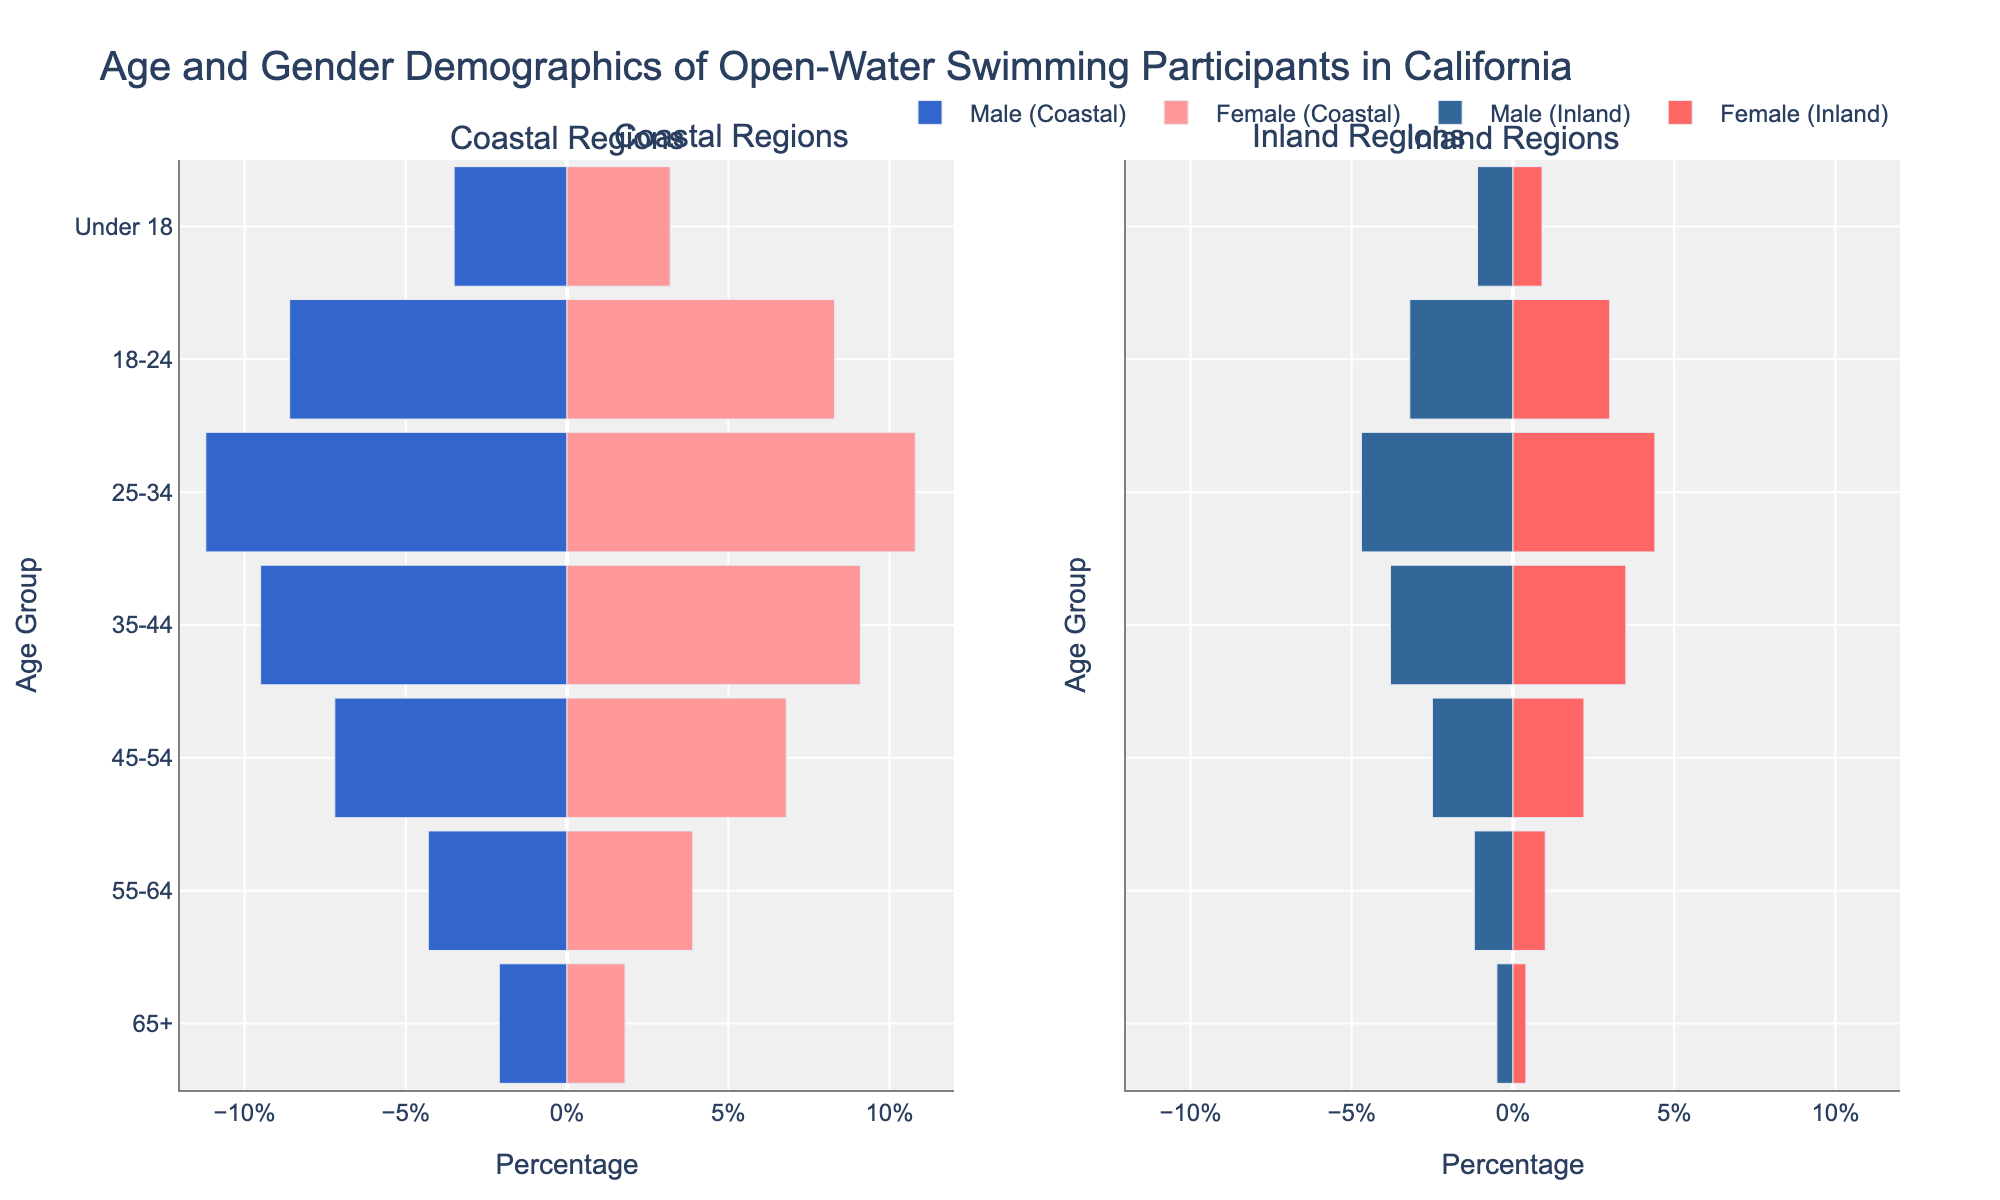What age group has the highest percentage of coastal male participants? To find the answer, look at the `Coastal Male` bar lengths. The age group 25-34 has the longest bar.
Answer: 25-34 Which region has a higher percentage of participants aged 18-24, coastal or inland? Compare the percentages of 18-24 year olds for both regions. Coastal has 8.6% males and 8.3% females, while inland has 3.2% males and 3.0% females. Coastal is higher in both cases.
Answer: Coastal How does the percentage of female participants in the 55-64 age group compare between coastal and inland regions? Compare the bar lengths for `Female (55-64)` in both regions. Coastal is 3.9% and inland is 1.0%. 3.9% is greater than 1.0%.
Answer: Coastal has a higher percentage What is the percentage difference between coastal and inland male participants in the 35-44 age group? Subtract the inland male percentage (3.8%) from the coastal male percentage (9.5%). 9.5% - 3.8% = 5.7%.
Answer: 5.7% In which region do males under 18 form a larger percentage of participants? Compare the `Under 18` male bars for both regions. Coastal males are at 3.5%, while inland males are at 1.1%.
Answer: Coastal Which gender shows a more balanced participation between coastal and inland regions for the 25-34 age group? Compare the differences in percentages for both genders: Coastal Male (11.2%) vs. Inland Male (4.7%) yields a difference of 6.5%, while Coastal Female (10.8%) vs. Inland Female (4.4%) yields a difference of 6.4%. Female participation is more balanced.
Answer: Female What is the total percentage of participants aged 55-64 in inland regions? Add the `Inland Male` and `Inland Female` percentages for 55-64. 1.2% + 1.0% = 2.2%.
Answer: 2.2% Which age group has the smallest difference in male participation percentages between coastal and inland regions? Calculate the differences for each age group. The results are: 65+ (2.1%-0.5%=1.6%), 55-64 (4.3%-1.2%=3.1%), 45-54 (7.2%-2.5%=4.7%), 35-44 (9.5%-3.8%=5.7%), 25-34 (11.2%-4.7%=6.5%), 18-24 (8.6%-3.2%=5.4%), Under 18 (3.5%-1.1%=2.4%). The smallest difference is for the 65+ group, which is 1.6%.
Answer: 65+ 